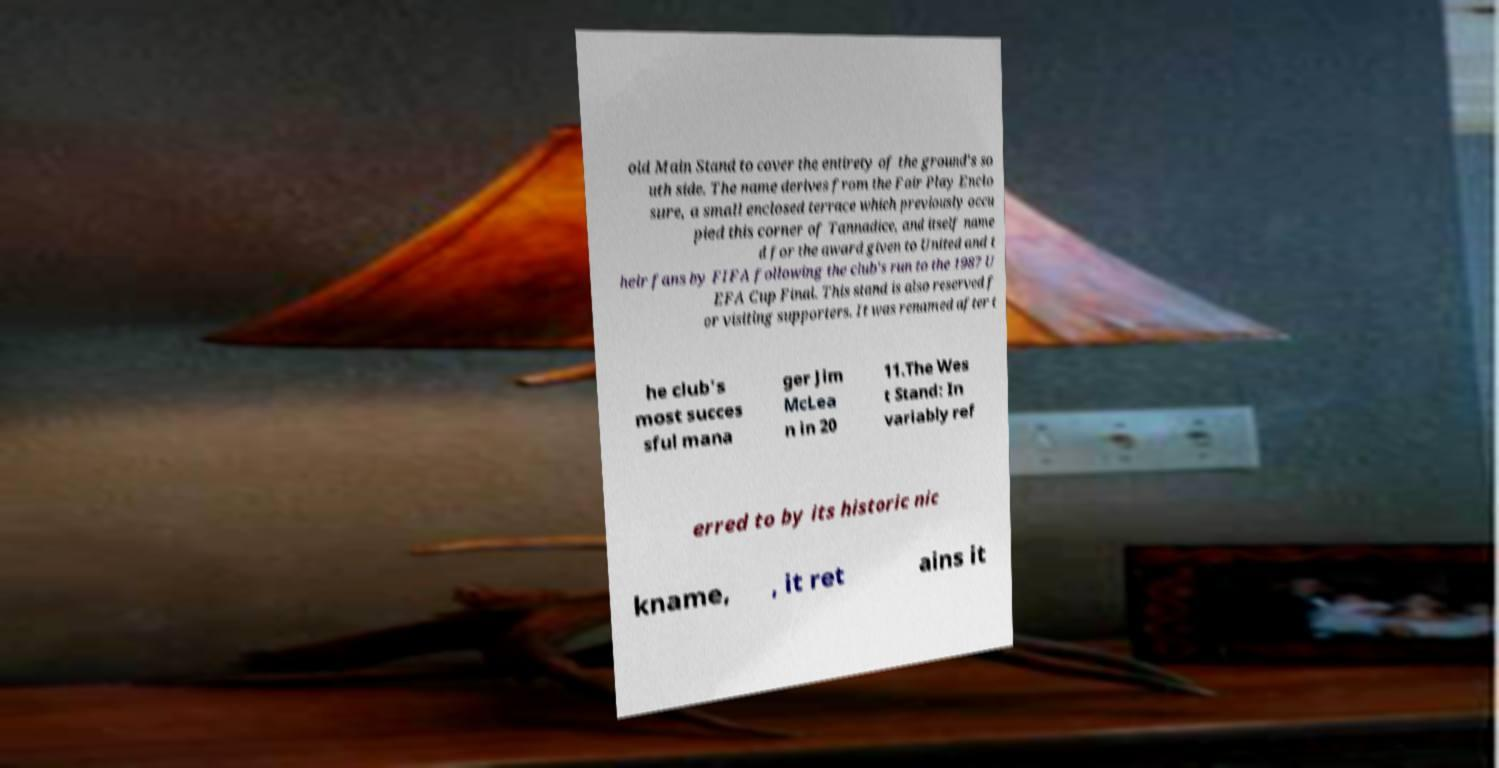Could you assist in decoding the text presented in this image and type it out clearly? old Main Stand to cover the entirety of the ground's so uth side. The name derives from the Fair Play Enclo sure, a small enclosed terrace which previously occu pied this corner of Tannadice, and itself name d for the award given to United and t heir fans by FIFA following the club's run to the 1987 U EFA Cup Final. This stand is also reserved f or visiting supporters. It was renamed after t he club's most succes sful mana ger Jim McLea n in 20 11.The Wes t Stand: In variably ref erred to by its historic nic kname, , it ret ains it 